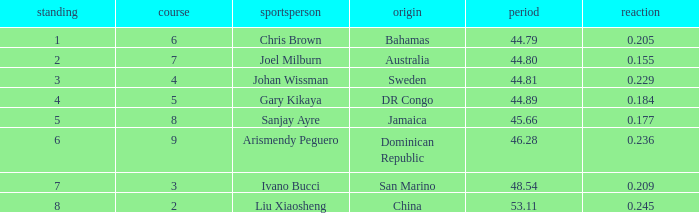What Lane has a 0.209 React entered with a Rank entry that is larger than 6? 2.0. Help me parse the entirety of this table. {'header': ['standing', 'course', 'sportsperson', 'origin', 'period', 'reaction'], 'rows': [['1', '6', 'Chris Brown', 'Bahamas', '44.79', '0.205'], ['2', '7', 'Joel Milburn', 'Australia', '44.80', '0.155'], ['3', '4', 'Johan Wissman', 'Sweden', '44.81', '0.229'], ['4', '5', 'Gary Kikaya', 'DR Congo', '44.89', '0.184'], ['5', '8', 'Sanjay Ayre', 'Jamaica', '45.66', '0.177'], ['6', '9', 'Arismendy Peguero', 'Dominican Republic', '46.28', '0.236'], ['7', '3', 'Ivano Bucci', 'San Marino', '48.54', '0.209'], ['8', '2', 'Liu Xiaosheng', 'China', '53.11', '0.245']]} 